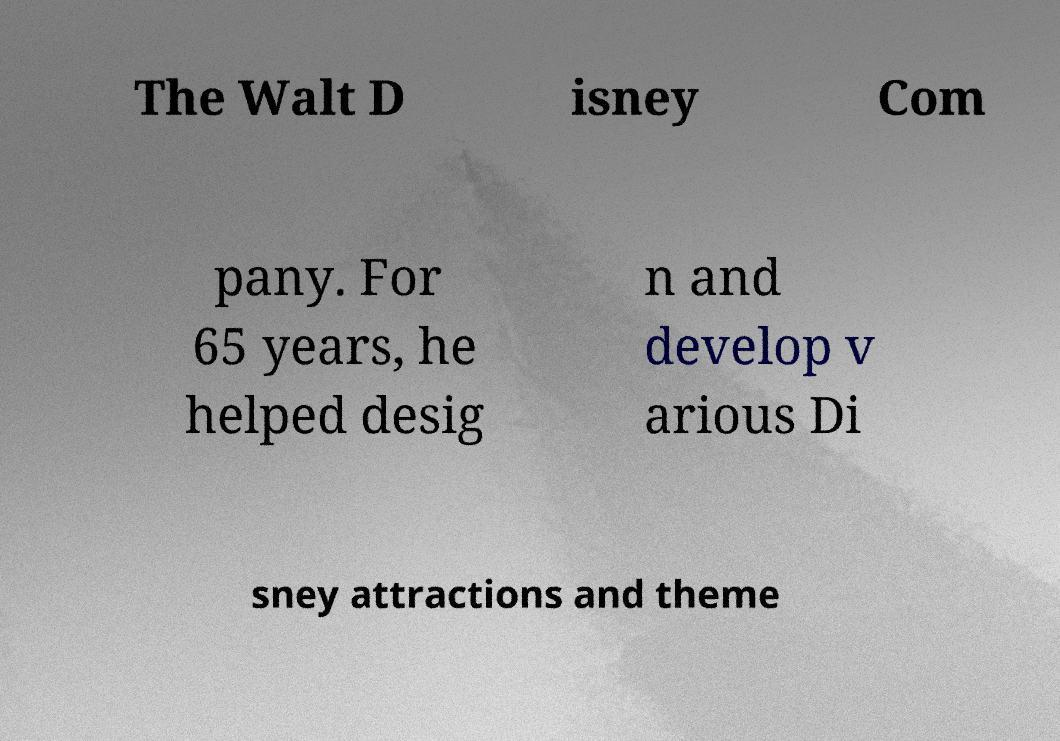Can you accurately transcribe the text from the provided image for me? The Walt D isney Com pany. For 65 years, he helped desig n and develop v arious Di sney attractions and theme 